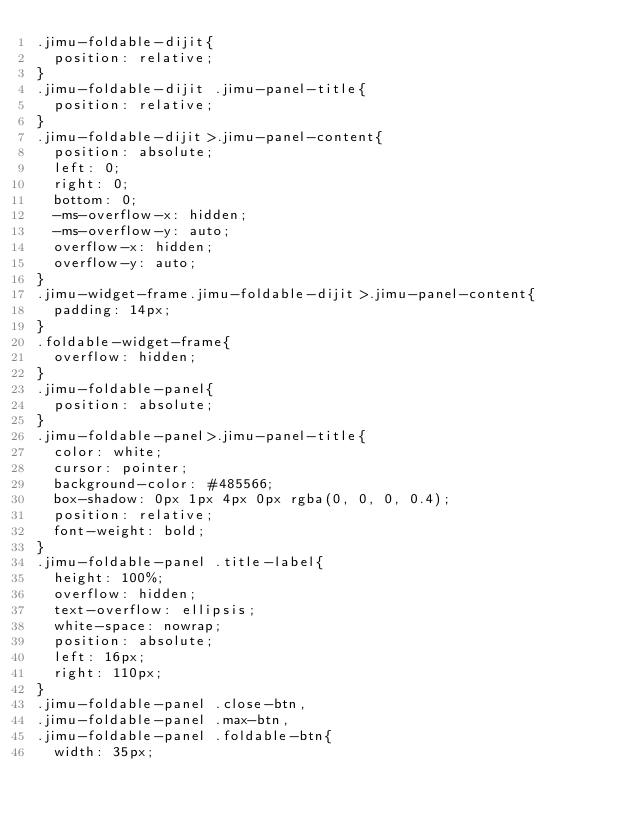Convert code to text. <code><loc_0><loc_0><loc_500><loc_500><_CSS_>.jimu-foldable-dijit{
  position: relative;
}
.jimu-foldable-dijit .jimu-panel-title{
  position: relative;
}
.jimu-foldable-dijit>.jimu-panel-content{
  position: absolute;
  left: 0;
  right: 0;
  bottom: 0;
  -ms-overflow-x: hidden;
  -ms-overflow-y: auto;
  overflow-x: hidden;
  overflow-y: auto;
}
.jimu-widget-frame.jimu-foldable-dijit>.jimu-panel-content{
  padding: 14px;
}
.foldable-widget-frame{
  overflow: hidden;
}
.jimu-foldable-panel{
  position: absolute;
}
.jimu-foldable-panel>.jimu-panel-title{
  color: white;
  cursor: pointer;
  background-color: #485566;
  box-shadow: 0px 1px 4px 0px rgba(0, 0, 0, 0.4);
  position: relative;
  font-weight: bold;
}
.jimu-foldable-panel .title-label{
  height: 100%;
  overflow: hidden;
  text-overflow: ellipsis;
  white-space: nowrap;
  position: absolute;
  left: 16px;
  right: 110px;
}
.jimu-foldable-panel .close-btn,
.jimu-foldable-panel .max-btn,
.jimu-foldable-panel .foldable-btn{
  width: 35px;</code> 